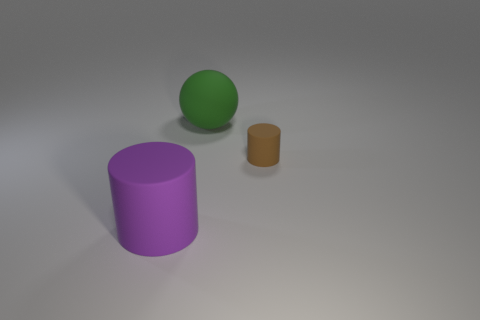Add 3 green rubber spheres. How many objects exist? 6 Subtract all spheres. How many objects are left? 2 Subtract 1 balls. How many balls are left? 0 Add 3 small brown objects. How many small brown objects exist? 4 Subtract 1 green balls. How many objects are left? 2 Subtract all purple cylinders. Subtract all gray balls. How many cylinders are left? 1 Subtract all blue cubes. How many blue cylinders are left? 0 Subtract all large metal spheres. Subtract all big balls. How many objects are left? 2 Add 2 big matte cylinders. How many big matte cylinders are left? 3 